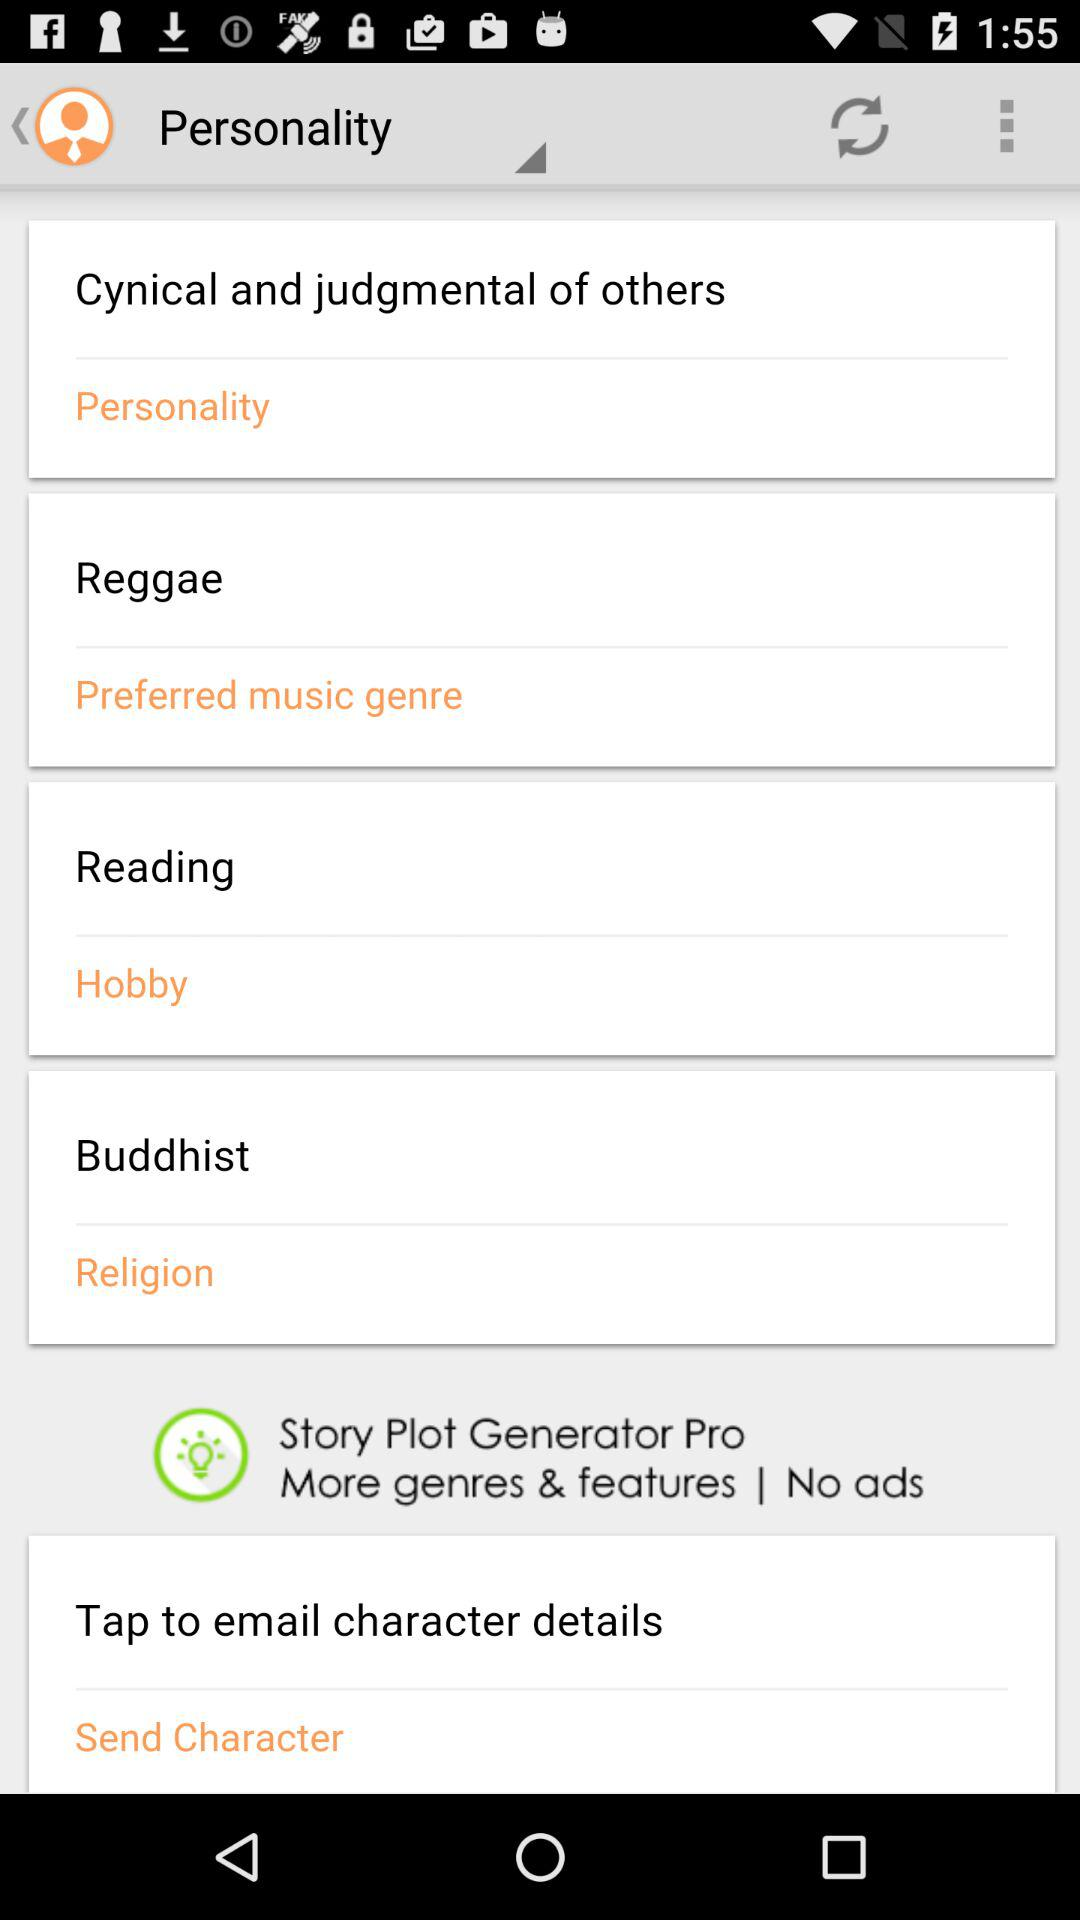What is the mentioned religion? The mentioned religion is Buddhism. 